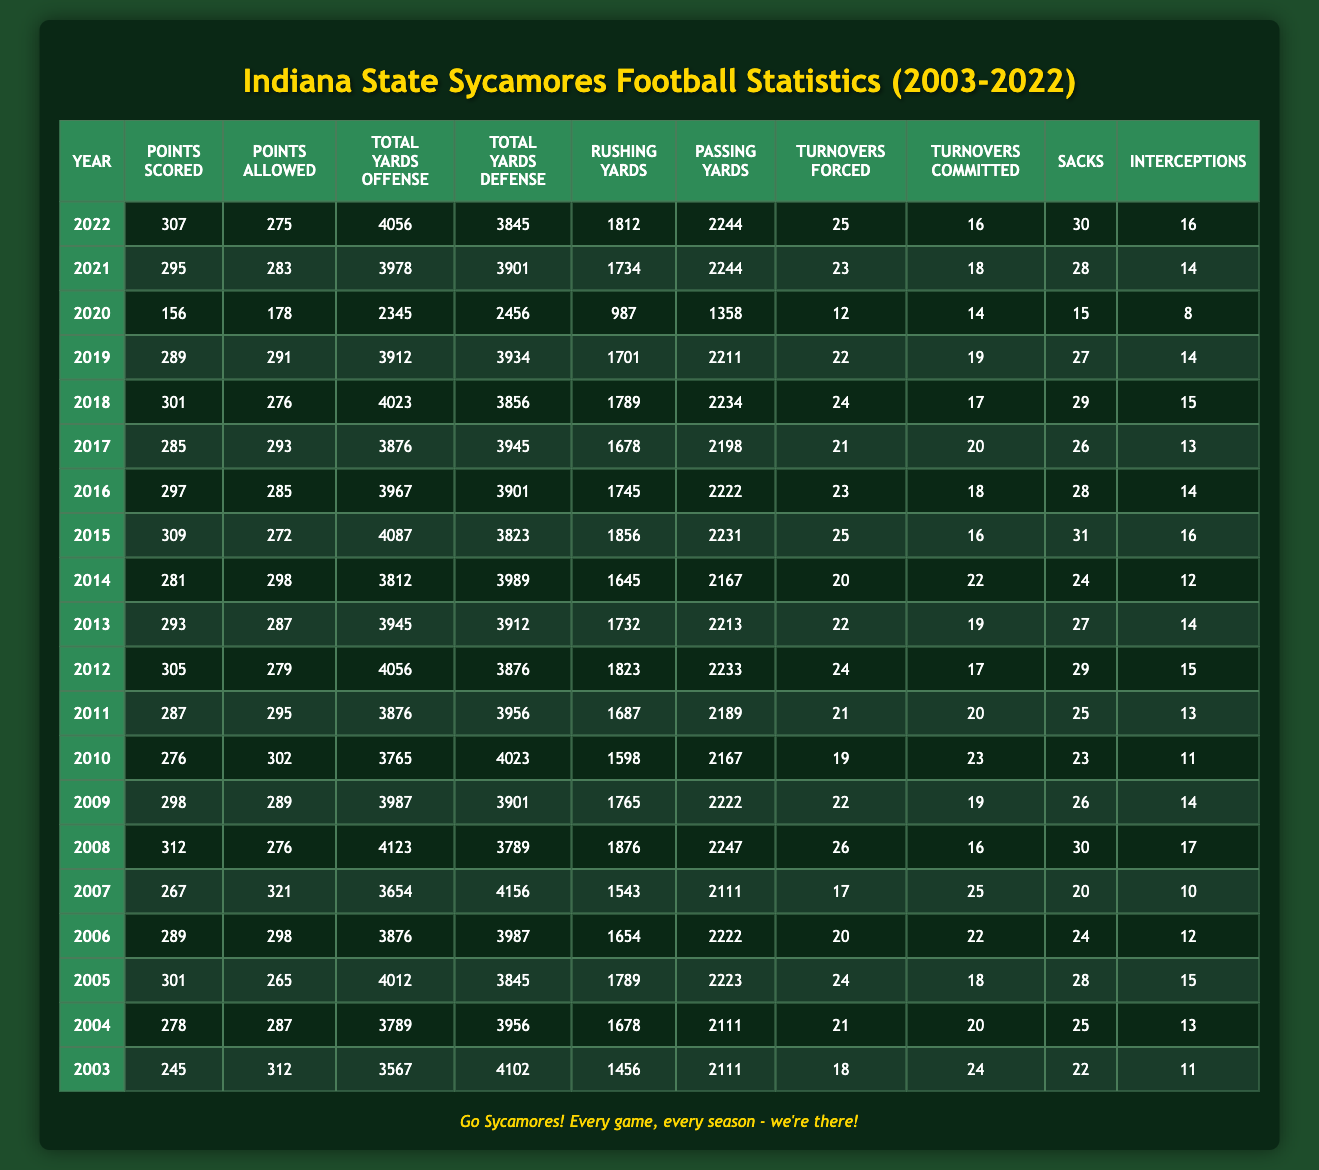What's the total points scored by the team in 2010? From the table, under the "Points Scored" column in the row for the year 2010, the value is 276.
Answer: 276 What was the team's best offensive yardage year? To find the year with the highest value in the "Total Yards Offense" column, we look through all rows. The highest value is 4123, which corresponds to the year 2008.
Answer: 2008 Did the Indiana State Sycamores score more points than they allowed in 2015? In the year 2015, the "Points Scored" is 309 and the "Points Allowed" is 272. Since 309 > 272, the team scored more points than they allowed.
Answer: Yes What is the average number of turnovers committed by the team over the last 5 seasons (2018-2022)? The number of turnovers committed for the years 2018 through 2022 are 17, 20, 18, 16, and 14. First, sum these values: 17 + 20 + 18 + 16 + 14 = 85. Then, divide by the number of seasons: 85 / 5 = 17.
Answer: 17 In how many seasons did the team have more rushing yards than passing yards? Review each year and compare the "Rushing Yards" and "Passing Yards" columns. The years with more rushing yards than passing yards are 2004, 2005, 2008, 2015, and 2016. This totals to 5 years where rushing yards exceeded passing yards.
Answer: 5 What was the highest number of interceptions thrown by the team in one year? Scanning the "Interceptions" column for the maximum value, we find the highest is 17 in the year 2008.
Answer: 17 Which year had the highest number of turnovers forced? From the "Turnovers Forced" column, the maximum value is 26, which occurred in the year 2008.
Answer: 2008 What is the total number of points scored by the team from 2003 to 2007? To find the total points scored from 2003 to 2007, sum the "Points Scored" values for those years: 245 + 278 + 301 + 289 + 267 = 1380.
Answer: 1380 How many points did the Indiana State Sycamores allow in the year with the lowest points scored? Looking at the "Points Allowed" column, the lowest points scored was 156 in the year 2020. The corresponding "Points Allowed" that year is 178.
Answer: 178 